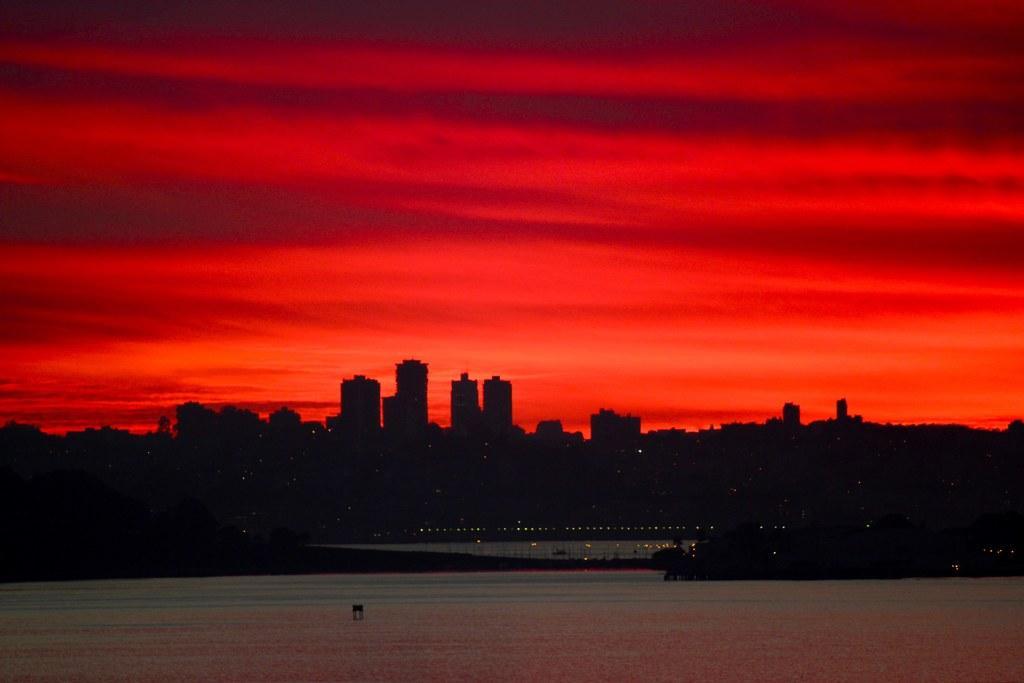Can you describe this image briefly? At the bottom of the image there is water. In the background there are buildings and there are lights. At the top of the image there is sky. 